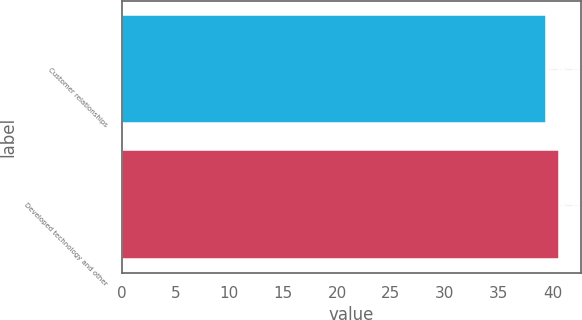Convert chart to OTSL. <chart><loc_0><loc_0><loc_500><loc_500><bar_chart><fcel>Customer relationships<fcel>Developed technology and other<nl><fcel>39.4<fcel>40.6<nl></chart> 